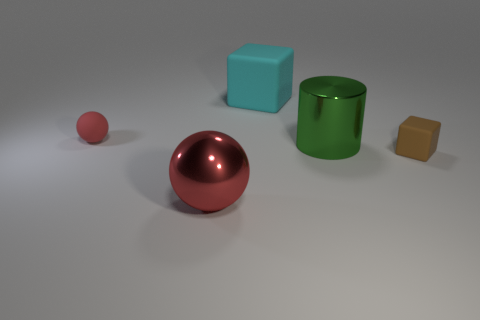Are there the same number of cylinders that are on the left side of the big cylinder and metal cylinders?
Provide a succinct answer. No. Does the small thing behind the green shiny cylinder have the same material as the tiny brown block that is in front of the red matte object?
Your response must be concise. Yes. How many things are big spheres or large metal things on the left side of the large rubber thing?
Provide a succinct answer. 1. Is there a big brown thing of the same shape as the small red thing?
Your answer should be compact. No. There is a block in front of the red thing that is on the left side of the big metal thing to the left of the big cyan matte cube; how big is it?
Make the answer very short. Small. Are there an equal number of big matte objects that are to the right of the small red matte sphere and cyan rubber cubes to the left of the metallic ball?
Provide a short and direct response. No. There is a red thing that is made of the same material as the cyan cube; what is its size?
Your response must be concise. Small. The small rubber sphere has what color?
Make the answer very short. Red. How many balls have the same color as the cylinder?
Provide a succinct answer. 0. There is a block that is the same size as the metallic ball; what material is it?
Provide a succinct answer. Rubber. 